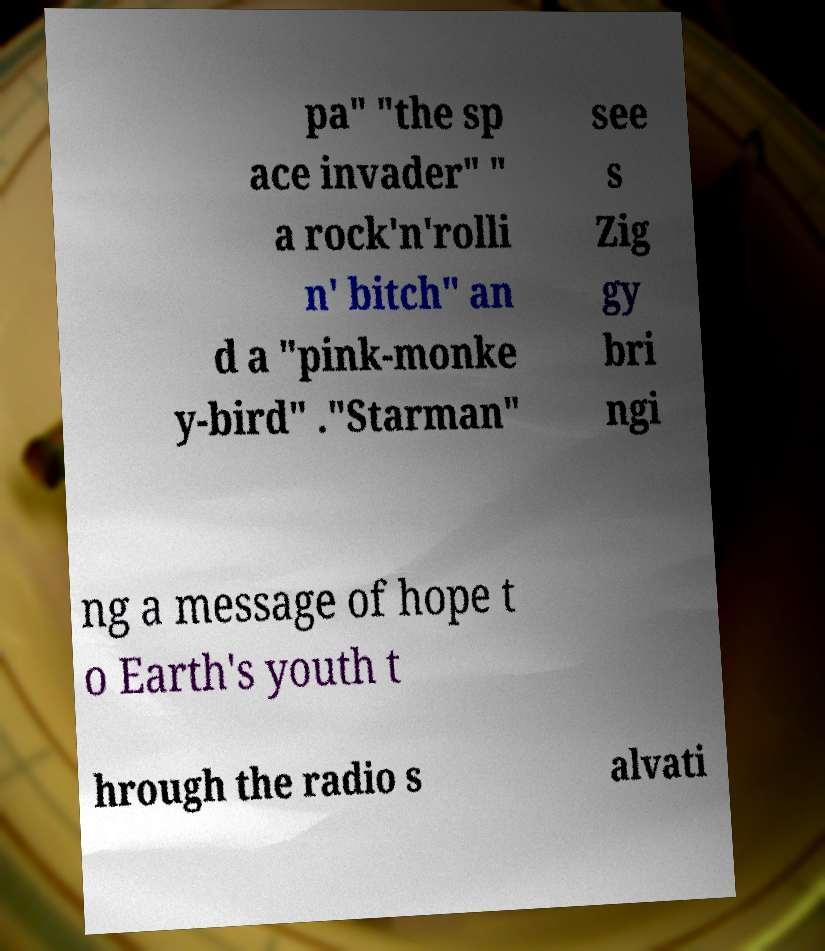I need the written content from this picture converted into text. Can you do that? pa" "the sp ace invader" " a rock'n'rolli n' bitch" an d a "pink-monke y-bird" ."Starman" see s Zig gy bri ngi ng a message of hope t o Earth's youth t hrough the radio s alvati 